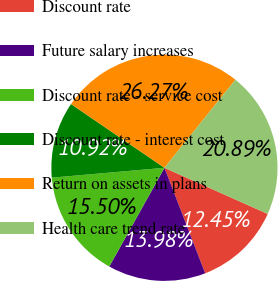<chart> <loc_0><loc_0><loc_500><loc_500><pie_chart><fcel>Discount rate<fcel>Future salary increases<fcel>Discount rate - service cost<fcel>Discount rate - interest cost<fcel>Return on assets in plans<fcel>Health care trend rate<nl><fcel>12.45%<fcel>13.98%<fcel>15.5%<fcel>10.92%<fcel>26.27%<fcel>20.89%<nl></chart> 